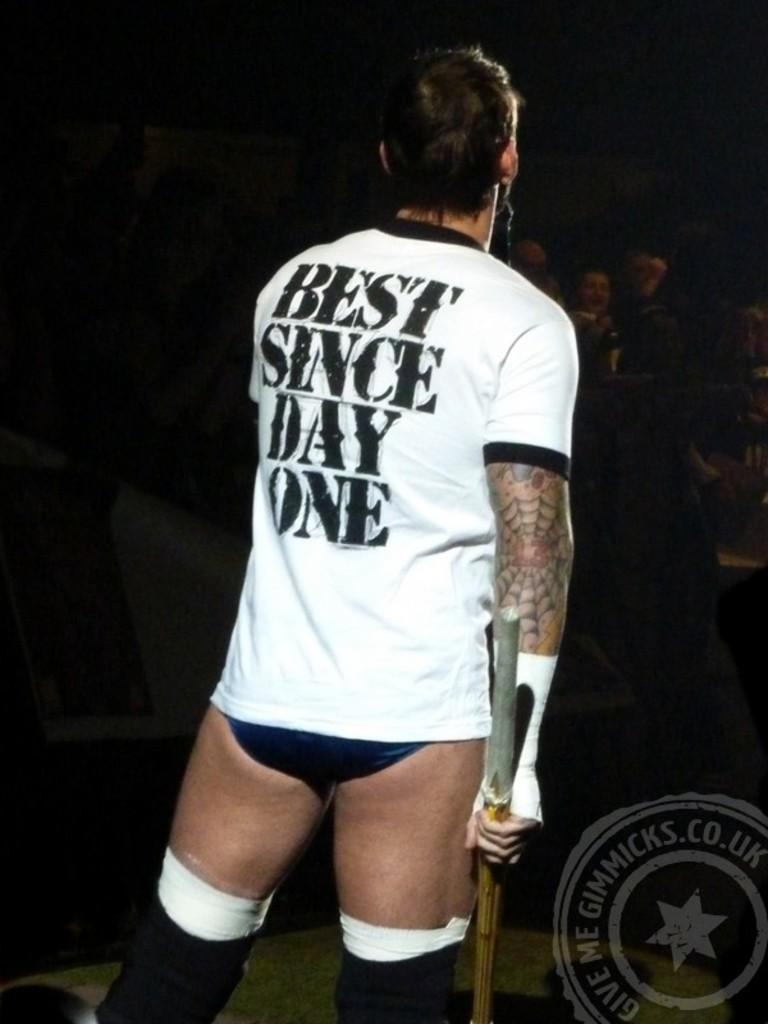<image>
Write a terse but informative summary of the picture. The man has a white shirt that says "Best Since Day One." 